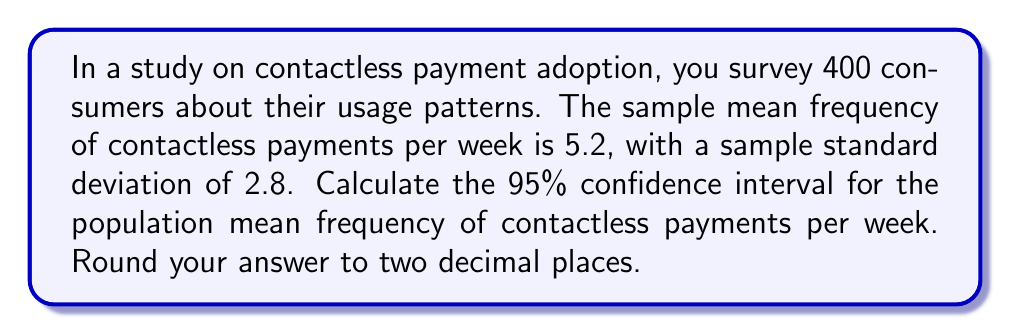Could you help me with this problem? To calculate the confidence interval, we'll use the formula:

$$ \text{CI} = \bar{x} \pm t_{\alpha/2, n-1} \cdot \frac{s}{\sqrt{n}} $$

Where:
- $\bar{x}$ is the sample mean (5.2)
- $s$ is the sample standard deviation (2.8)
- $n$ is the sample size (400)
- $t_{\alpha/2, n-1}$ is the t-value for a 95% confidence interval with 399 degrees of freedom

Steps:
1) For a large sample size (n > 30), the t-distribution approaches the normal distribution. We can use the z-score of 1.96 for a 95% confidence interval.

2) Calculate the standard error:
   $$ SE = \frac{s}{\sqrt{n}} = \frac{2.8}{\sqrt{400}} = 0.14 $$

3) Calculate the margin of error:
   $$ ME = 1.96 \cdot SE = 1.96 \cdot 0.14 = 0.2744 $$

4) Calculate the confidence interval:
   $$ \text{CI} = 5.2 \pm 0.2744 $$
   $$ \text{Lower bound} = 5.2 - 0.2744 = 4.9256 $$
   $$ \text{Upper bound} = 5.2 + 0.2744 = 5.4744 $$

5) Round to two decimal places:
   $$ \text{CI} = (4.93, 5.47) $$
Answer: The 95% confidence interval for the population mean frequency of contactless payments per week is (4.93, 5.47). 